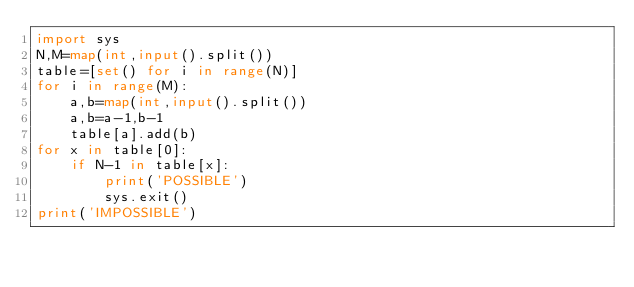Convert code to text. <code><loc_0><loc_0><loc_500><loc_500><_Python_>import sys
N,M=map(int,input().split())
table=[set() for i in range(N)]
for i in range(M):
    a,b=map(int,input().split())
    a,b=a-1,b-1
    table[a].add(b)
for x in table[0]:
    if N-1 in table[x]:
        print('POSSIBLE')
        sys.exit()
print('IMPOSSIBLE')</code> 